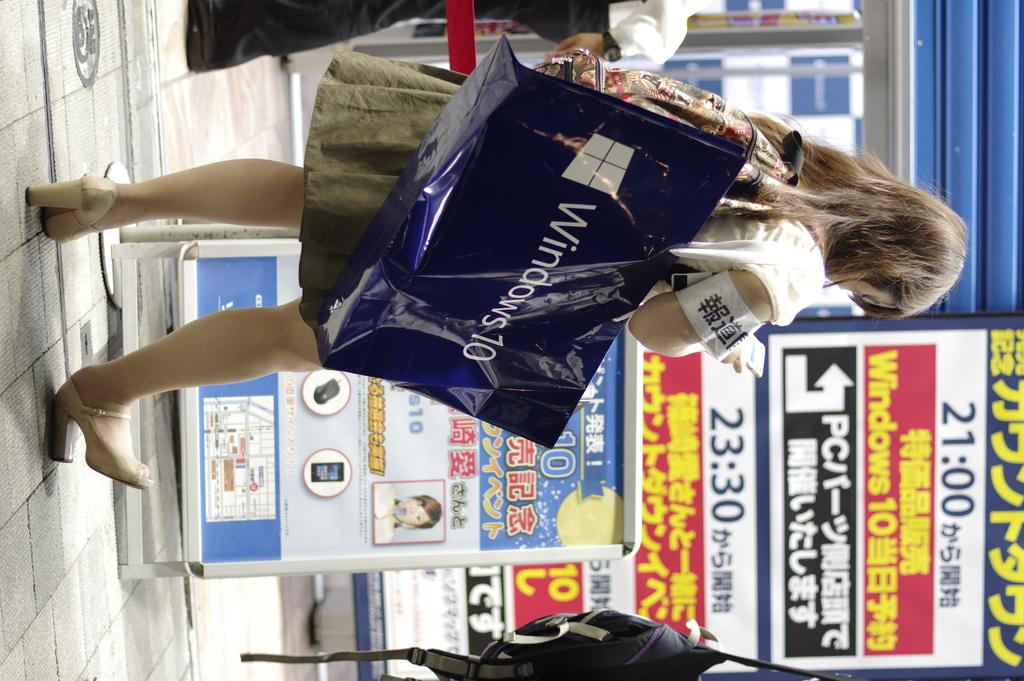<image>
Summarize the visual content of the image. A girl with a blue bag on her shoulder that says Windows 10 